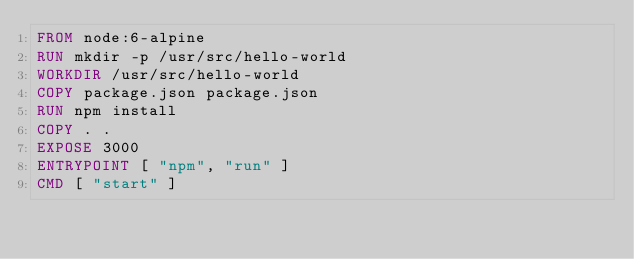<code> <loc_0><loc_0><loc_500><loc_500><_Dockerfile_>FROM node:6-alpine
RUN mkdir -p /usr/src/hello-world
WORKDIR /usr/src/hello-world
COPY package.json package.json
RUN npm install
COPY . .
EXPOSE 3000
ENTRYPOINT [ "npm", "run" ]
CMD [ "start" ]
</code> 